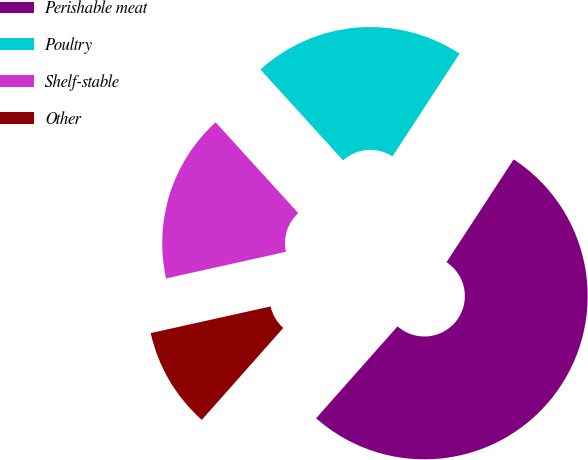Convert chart to OTSL. <chart><loc_0><loc_0><loc_500><loc_500><pie_chart><fcel>Perishable meat<fcel>Poultry<fcel>Shelf-stable<fcel>Other<nl><fcel>52.33%<fcel>20.96%<fcel>16.73%<fcel>9.98%<nl></chart> 